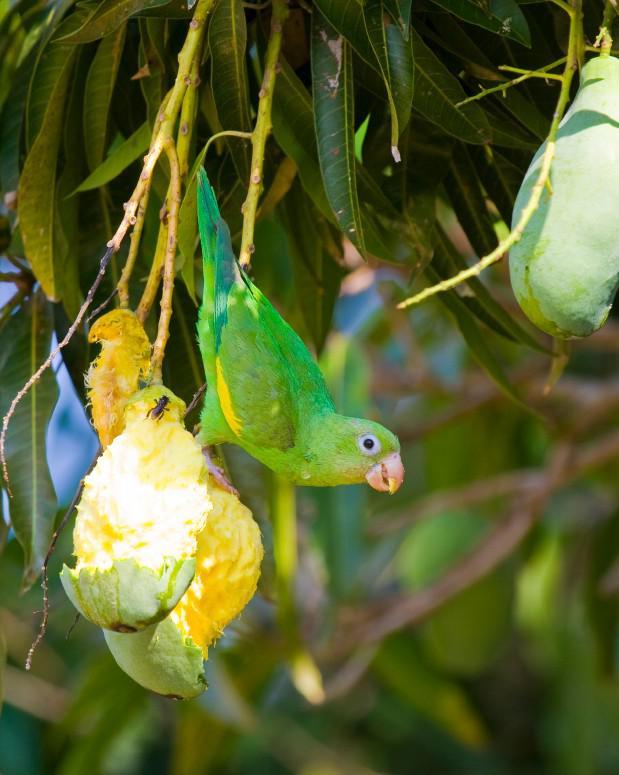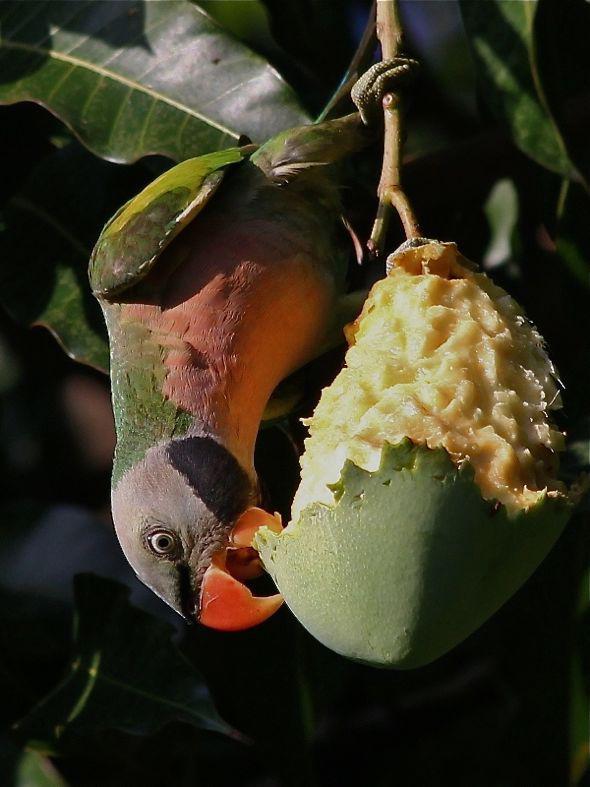The first image is the image on the left, the second image is the image on the right. Examine the images to the left and right. Is the description "The right image shows a single toucan that has an orange beak and is upside down." accurate? Answer yes or no. Yes. The first image is the image on the left, the second image is the image on the right. Given the left and right images, does the statement "In the image on the right, a lone parrot/parakeet eats fruit, while hanging upside-down." hold true? Answer yes or no. Yes. 